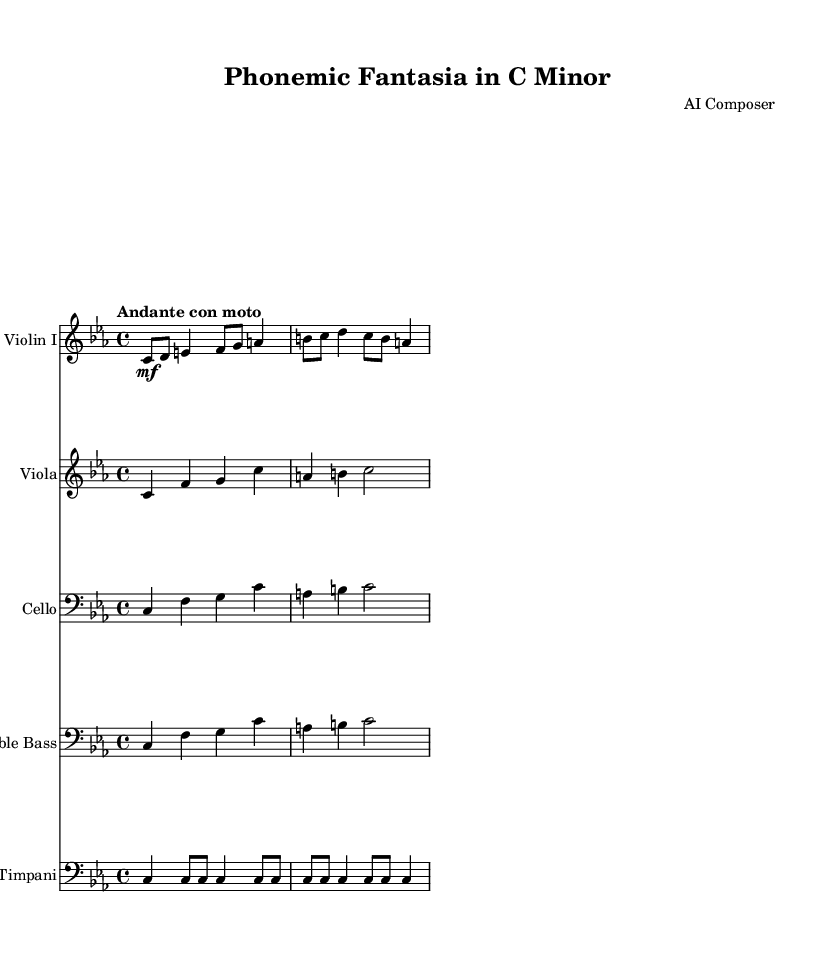What is the key signature of this music? The key signature is C minor, which is indicated by three flats. This can be identified by looking at the key signature section at the beginning of the staff.
Answer: C minor What is the time signature of this piece? The time signature is 4/4, which means there are four beats in each measure. This is visually represented at the start of the score.
Answer: 4/4 What is the tempo marking of the piece? The tempo marking is "Andante con moto", which indicates a moderately slow tempo with some motion. This is found in the tempo section at the beginning of the score.
Answer: Andante con moto How many measures are present in the violin part? The violin part contains four measures, which can be counted by looking at the groupings of the notes between the bar lines.
Answer: Four What is the highest pitch used in the viola part? The highest pitch in the viola part is C, which can be found by analyzing the notes written in the staff. The highest note is in the second measure.
Answer: C How does the cello's rhythmic pattern compare to the piano's? The cello shares the same rhythmic pattern as the piano with consistent quarter note rhythms in each measure, giving them a uniformity in the beat structure across the sections.
Answer: Same What unique element distinguishes this symphony in its incorporation of phonetics? The symphony uniquely integrates linguistic tonal patterns, reflected in its melodic contours which can be interpreted as emulating acoustic patterns found in human speech.
Answer: Linguistic tonal patterns 